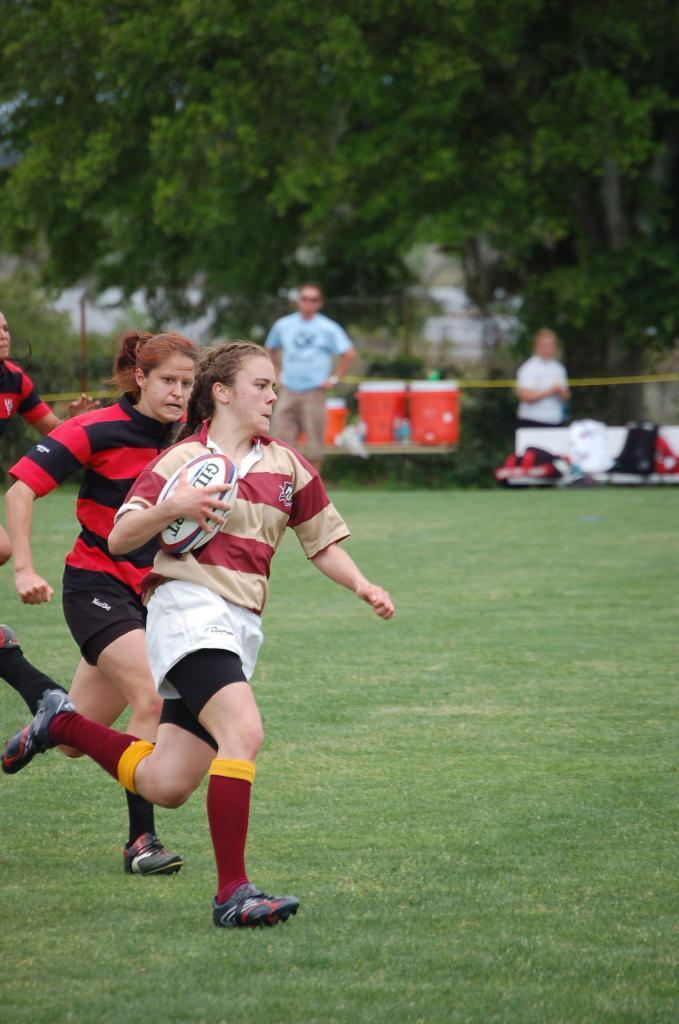In one or two sentences, can you explain what this image depicts? There is a garden, in that there are some women running, a woman holding a golf ball and running ,there are some who are standing and looking and in the background there is a big green tree. 